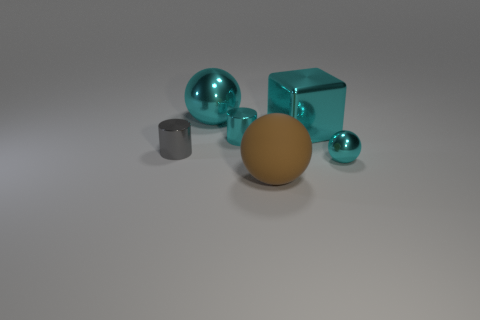There is a tiny ball that is the same color as the large metal block; what is it made of?
Provide a short and direct response. Metal. What is the size of the block that is the same color as the tiny sphere?
Your answer should be very brief. Large. Do the big block and the small ball have the same color?
Provide a succinct answer. Yes. What is the shape of the large metallic object that is the same color as the block?
Keep it short and to the point. Sphere. Are there any other large blocks that have the same color as the block?
Keep it short and to the point. No. Are there fewer tiny cyan shiny cylinders on the left side of the cyan cylinder than big spheres in front of the big brown matte thing?
Provide a short and direct response. No. There is a cyan object that is to the left of the small metal ball and in front of the cyan block; what is its material?
Ensure brevity in your answer.  Metal. There is a brown matte thing; is its shape the same as the tiny metal object that is in front of the gray metal object?
Keep it short and to the point. Yes. What number of other things are the same size as the brown sphere?
Your answer should be very brief. 2. Are there more cubes than small red rubber objects?
Your answer should be compact. Yes. 